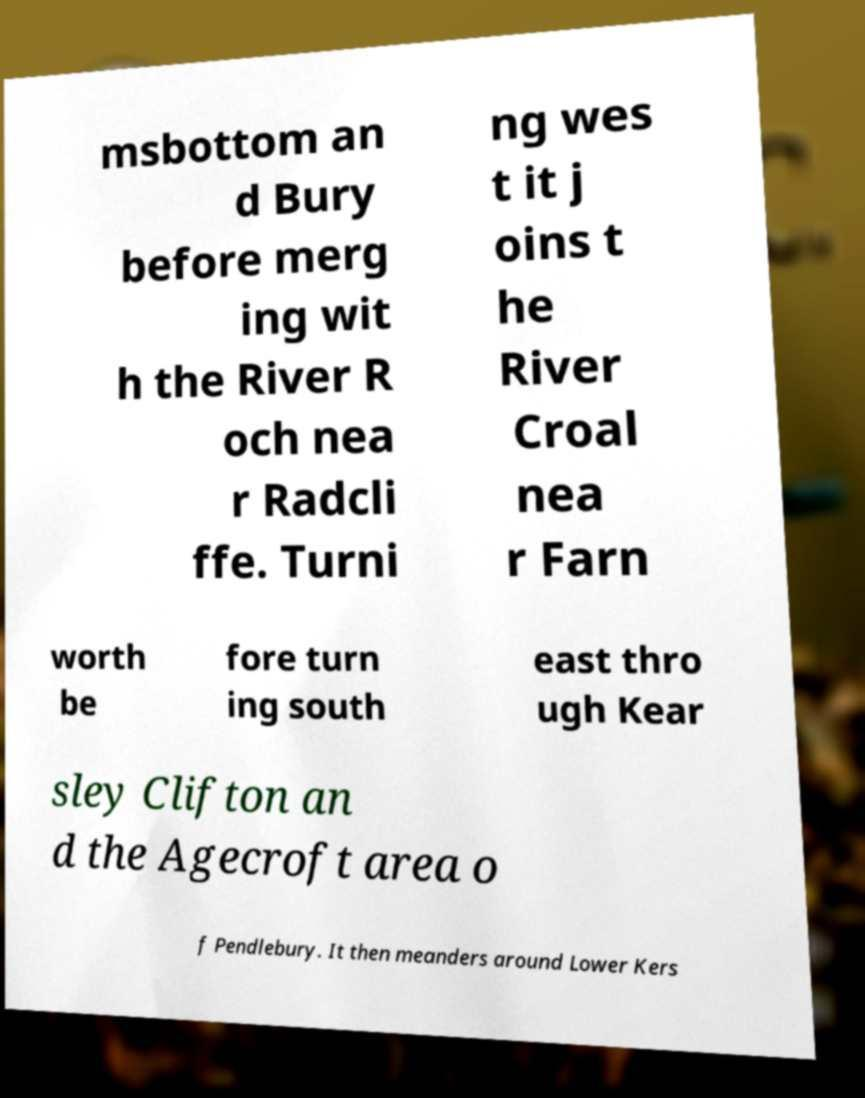There's text embedded in this image that I need extracted. Can you transcribe it verbatim? msbottom an d Bury before merg ing wit h the River R och nea r Radcli ffe. Turni ng wes t it j oins t he River Croal nea r Farn worth be fore turn ing south east thro ugh Kear sley Clifton an d the Agecroft area o f Pendlebury. It then meanders around Lower Kers 